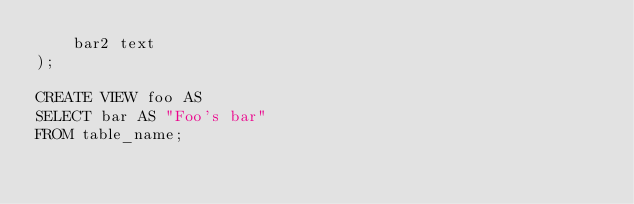<code> <loc_0><loc_0><loc_500><loc_500><_SQL_>    bar2 text
);

CREATE VIEW foo AS
SELECT bar AS "Foo's bar"
FROM table_name;</code> 